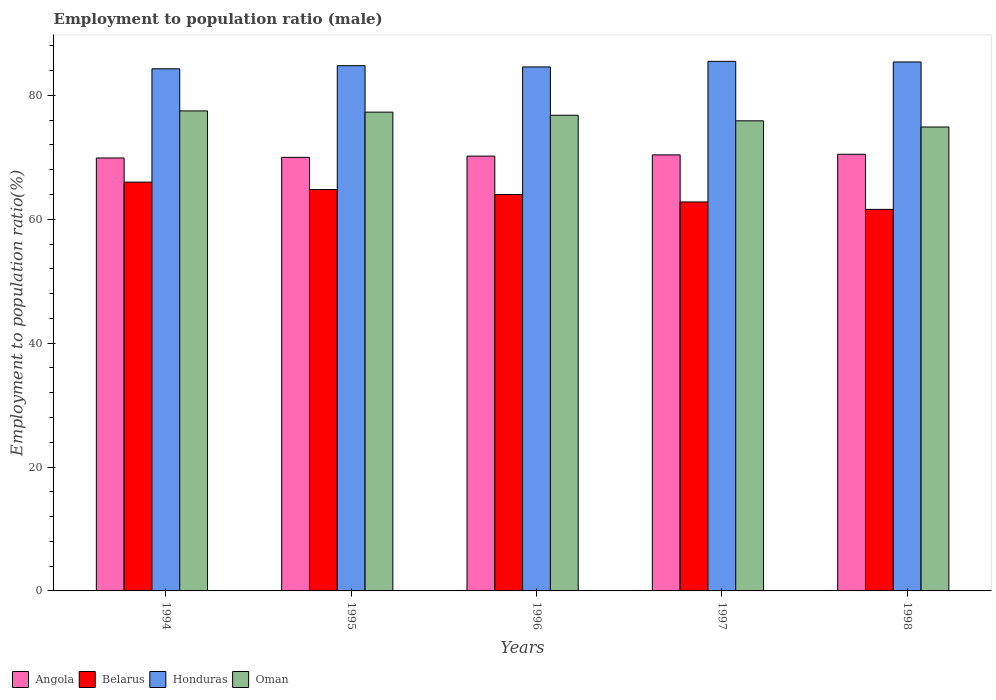Are the number of bars per tick equal to the number of legend labels?
Your response must be concise. Yes. How many bars are there on the 4th tick from the right?
Offer a very short reply. 4. What is the employment to population ratio in Honduras in 1994?
Your response must be concise. 84.3. Across all years, what is the maximum employment to population ratio in Oman?
Your response must be concise. 77.5. Across all years, what is the minimum employment to population ratio in Angola?
Your answer should be compact. 69.9. In which year was the employment to population ratio in Honduras maximum?
Provide a short and direct response. 1997. What is the total employment to population ratio in Honduras in the graph?
Give a very brief answer. 424.6. What is the difference between the employment to population ratio in Honduras in 1997 and that in 1998?
Offer a very short reply. 0.1. What is the difference between the employment to population ratio in Oman in 1998 and the employment to population ratio in Angola in 1995?
Provide a succinct answer. 4.9. What is the average employment to population ratio in Honduras per year?
Provide a succinct answer. 84.92. In the year 1995, what is the difference between the employment to population ratio in Belarus and employment to population ratio in Oman?
Your answer should be compact. -12.5. In how many years, is the employment to population ratio in Honduras greater than 20 %?
Give a very brief answer. 5. What is the ratio of the employment to population ratio in Oman in 1994 to that in 1997?
Offer a terse response. 1.02. Is the difference between the employment to population ratio in Belarus in 1994 and 1998 greater than the difference between the employment to population ratio in Oman in 1994 and 1998?
Make the answer very short. Yes. What is the difference between the highest and the second highest employment to population ratio in Oman?
Offer a very short reply. 0.2. What is the difference between the highest and the lowest employment to population ratio in Belarus?
Keep it short and to the point. 4.4. What does the 4th bar from the left in 1998 represents?
Your answer should be very brief. Oman. What does the 1st bar from the right in 1997 represents?
Your answer should be very brief. Oman. Is it the case that in every year, the sum of the employment to population ratio in Honduras and employment to population ratio in Belarus is greater than the employment to population ratio in Angola?
Your response must be concise. Yes. Are all the bars in the graph horizontal?
Offer a very short reply. No. Are the values on the major ticks of Y-axis written in scientific E-notation?
Offer a terse response. No. Where does the legend appear in the graph?
Make the answer very short. Bottom left. How many legend labels are there?
Keep it short and to the point. 4. What is the title of the graph?
Offer a terse response. Employment to population ratio (male). What is the label or title of the Y-axis?
Provide a succinct answer. Employment to population ratio(%). What is the Employment to population ratio(%) of Angola in 1994?
Give a very brief answer. 69.9. What is the Employment to population ratio(%) in Belarus in 1994?
Your answer should be very brief. 66. What is the Employment to population ratio(%) of Honduras in 1994?
Make the answer very short. 84.3. What is the Employment to population ratio(%) in Oman in 1994?
Your answer should be compact. 77.5. What is the Employment to population ratio(%) in Angola in 1995?
Your answer should be very brief. 70. What is the Employment to population ratio(%) of Belarus in 1995?
Offer a terse response. 64.8. What is the Employment to population ratio(%) in Honduras in 1995?
Offer a very short reply. 84.8. What is the Employment to population ratio(%) in Oman in 1995?
Provide a short and direct response. 77.3. What is the Employment to population ratio(%) in Angola in 1996?
Your answer should be compact. 70.2. What is the Employment to population ratio(%) in Belarus in 1996?
Make the answer very short. 64. What is the Employment to population ratio(%) of Honduras in 1996?
Your answer should be compact. 84.6. What is the Employment to population ratio(%) of Oman in 1996?
Give a very brief answer. 76.8. What is the Employment to population ratio(%) in Angola in 1997?
Your answer should be very brief. 70.4. What is the Employment to population ratio(%) of Belarus in 1997?
Keep it short and to the point. 62.8. What is the Employment to population ratio(%) in Honduras in 1997?
Your response must be concise. 85.5. What is the Employment to population ratio(%) of Oman in 1997?
Offer a very short reply. 75.9. What is the Employment to population ratio(%) of Angola in 1998?
Your answer should be very brief. 70.5. What is the Employment to population ratio(%) in Belarus in 1998?
Offer a very short reply. 61.6. What is the Employment to population ratio(%) in Honduras in 1998?
Offer a terse response. 85.4. What is the Employment to population ratio(%) of Oman in 1998?
Offer a terse response. 74.9. Across all years, what is the maximum Employment to population ratio(%) of Angola?
Offer a terse response. 70.5. Across all years, what is the maximum Employment to population ratio(%) of Honduras?
Provide a short and direct response. 85.5. Across all years, what is the maximum Employment to population ratio(%) in Oman?
Your response must be concise. 77.5. Across all years, what is the minimum Employment to population ratio(%) in Angola?
Keep it short and to the point. 69.9. Across all years, what is the minimum Employment to population ratio(%) of Belarus?
Give a very brief answer. 61.6. Across all years, what is the minimum Employment to population ratio(%) of Honduras?
Ensure brevity in your answer.  84.3. Across all years, what is the minimum Employment to population ratio(%) of Oman?
Your answer should be compact. 74.9. What is the total Employment to population ratio(%) in Angola in the graph?
Offer a terse response. 351. What is the total Employment to population ratio(%) in Belarus in the graph?
Give a very brief answer. 319.2. What is the total Employment to population ratio(%) of Honduras in the graph?
Provide a short and direct response. 424.6. What is the total Employment to population ratio(%) in Oman in the graph?
Give a very brief answer. 382.4. What is the difference between the Employment to population ratio(%) of Angola in 1994 and that in 1995?
Your answer should be very brief. -0.1. What is the difference between the Employment to population ratio(%) in Honduras in 1994 and that in 1995?
Give a very brief answer. -0.5. What is the difference between the Employment to population ratio(%) of Angola in 1994 and that in 1996?
Your answer should be compact. -0.3. What is the difference between the Employment to population ratio(%) in Belarus in 1994 and that in 1996?
Make the answer very short. 2. What is the difference between the Employment to population ratio(%) in Honduras in 1994 and that in 1996?
Offer a terse response. -0.3. What is the difference between the Employment to population ratio(%) of Oman in 1994 and that in 1996?
Provide a short and direct response. 0.7. What is the difference between the Employment to population ratio(%) in Angola in 1994 and that in 1997?
Give a very brief answer. -0.5. What is the difference between the Employment to population ratio(%) of Belarus in 1994 and that in 1997?
Keep it short and to the point. 3.2. What is the difference between the Employment to population ratio(%) of Angola in 1994 and that in 1998?
Make the answer very short. -0.6. What is the difference between the Employment to population ratio(%) of Belarus in 1994 and that in 1998?
Give a very brief answer. 4.4. What is the difference between the Employment to population ratio(%) in Honduras in 1994 and that in 1998?
Give a very brief answer. -1.1. What is the difference between the Employment to population ratio(%) of Belarus in 1995 and that in 1996?
Your response must be concise. 0.8. What is the difference between the Employment to population ratio(%) in Honduras in 1995 and that in 1996?
Make the answer very short. 0.2. What is the difference between the Employment to population ratio(%) of Angola in 1995 and that in 1998?
Your answer should be compact. -0.5. What is the difference between the Employment to population ratio(%) of Belarus in 1995 and that in 1998?
Your answer should be very brief. 3.2. What is the difference between the Employment to population ratio(%) of Oman in 1995 and that in 1998?
Your response must be concise. 2.4. What is the difference between the Employment to population ratio(%) of Belarus in 1996 and that in 1997?
Your answer should be compact. 1.2. What is the difference between the Employment to population ratio(%) of Honduras in 1996 and that in 1997?
Give a very brief answer. -0.9. What is the difference between the Employment to population ratio(%) in Oman in 1996 and that in 1997?
Make the answer very short. 0.9. What is the difference between the Employment to population ratio(%) of Honduras in 1996 and that in 1998?
Your answer should be compact. -0.8. What is the difference between the Employment to population ratio(%) of Angola in 1997 and that in 1998?
Your answer should be very brief. -0.1. What is the difference between the Employment to population ratio(%) of Belarus in 1997 and that in 1998?
Make the answer very short. 1.2. What is the difference between the Employment to population ratio(%) of Oman in 1997 and that in 1998?
Provide a short and direct response. 1. What is the difference between the Employment to population ratio(%) in Angola in 1994 and the Employment to population ratio(%) in Belarus in 1995?
Keep it short and to the point. 5.1. What is the difference between the Employment to population ratio(%) of Angola in 1994 and the Employment to population ratio(%) of Honduras in 1995?
Your answer should be very brief. -14.9. What is the difference between the Employment to population ratio(%) of Angola in 1994 and the Employment to population ratio(%) of Oman in 1995?
Provide a short and direct response. -7.4. What is the difference between the Employment to population ratio(%) in Belarus in 1994 and the Employment to population ratio(%) in Honduras in 1995?
Keep it short and to the point. -18.8. What is the difference between the Employment to population ratio(%) in Belarus in 1994 and the Employment to population ratio(%) in Oman in 1995?
Make the answer very short. -11.3. What is the difference between the Employment to population ratio(%) of Honduras in 1994 and the Employment to population ratio(%) of Oman in 1995?
Your answer should be very brief. 7. What is the difference between the Employment to population ratio(%) of Angola in 1994 and the Employment to population ratio(%) of Belarus in 1996?
Keep it short and to the point. 5.9. What is the difference between the Employment to population ratio(%) of Angola in 1994 and the Employment to population ratio(%) of Honduras in 1996?
Provide a short and direct response. -14.7. What is the difference between the Employment to population ratio(%) in Angola in 1994 and the Employment to population ratio(%) in Oman in 1996?
Ensure brevity in your answer.  -6.9. What is the difference between the Employment to population ratio(%) in Belarus in 1994 and the Employment to population ratio(%) in Honduras in 1996?
Offer a very short reply. -18.6. What is the difference between the Employment to population ratio(%) of Honduras in 1994 and the Employment to population ratio(%) of Oman in 1996?
Your answer should be very brief. 7.5. What is the difference between the Employment to population ratio(%) in Angola in 1994 and the Employment to population ratio(%) in Belarus in 1997?
Your answer should be compact. 7.1. What is the difference between the Employment to population ratio(%) of Angola in 1994 and the Employment to population ratio(%) of Honduras in 1997?
Your answer should be compact. -15.6. What is the difference between the Employment to population ratio(%) of Belarus in 1994 and the Employment to population ratio(%) of Honduras in 1997?
Offer a very short reply. -19.5. What is the difference between the Employment to population ratio(%) in Belarus in 1994 and the Employment to population ratio(%) in Oman in 1997?
Your answer should be compact. -9.9. What is the difference between the Employment to population ratio(%) in Angola in 1994 and the Employment to population ratio(%) in Honduras in 1998?
Provide a succinct answer. -15.5. What is the difference between the Employment to population ratio(%) of Belarus in 1994 and the Employment to population ratio(%) of Honduras in 1998?
Your answer should be compact. -19.4. What is the difference between the Employment to population ratio(%) of Belarus in 1994 and the Employment to population ratio(%) of Oman in 1998?
Ensure brevity in your answer.  -8.9. What is the difference between the Employment to population ratio(%) in Honduras in 1994 and the Employment to population ratio(%) in Oman in 1998?
Your answer should be very brief. 9.4. What is the difference between the Employment to population ratio(%) in Angola in 1995 and the Employment to population ratio(%) in Belarus in 1996?
Your answer should be very brief. 6. What is the difference between the Employment to population ratio(%) in Angola in 1995 and the Employment to population ratio(%) in Honduras in 1996?
Give a very brief answer. -14.6. What is the difference between the Employment to population ratio(%) of Angola in 1995 and the Employment to population ratio(%) of Oman in 1996?
Ensure brevity in your answer.  -6.8. What is the difference between the Employment to population ratio(%) of Belarus in 1995 and the Employment to population ratio(%) of Honduras in 1996?
Provide a succinct answer. -19.8. What is the difference between the Employment to population ratio(%) of Angola in 1995 and the Employment to population ratio(%) of Honduras in 1997?
Make the answer very short. -15.5. What is the difference between the Employment to population ratio(%) in Angola in 1995 and the Employment to population ratio(%) in Oman in 1997?
Offer a very short reply. -5.9. What is the difference between the Employment to population ratio(%) in Belarus in 1995 and the Employment to population ratio(%) in Honduras in 1997?
Keep it short and to the point. -20.7. What is the difference between the Employment to population ratio(%) of Angola in 1995 and the Employment to population ratio(%) of Belarus in 1998?
Keep it short and to the point. 8.4. What is the difference between the Employment to population ratio(%) in Angola in 1995 and the Employment to population ratio(%) in Honduras in 1998?
Offer a very short reply. -15.4. What is the difference between the Employment to population ratio(%) of Belarus in 1995 and the Employment to population ratio(%) of Honduras in 1998?
Provide a succinct answer. -20.6. What is the difference between the Employment to population ratio(%) of Angola in 1996 and the Employment to population ratio(%) of Honduras in 1997?
Offer a terse response. -15.3. What is the difference between the Employment to population ratio(%) of Angola in 1996 and the Employment to population ratio(%) of Oman in 1997?
Offer a terse response. -5.7. What is the difference between the Employment to population ratio(%) in Belarus in 1996 and the Employment to population ratio(%) in Honduras in 1997?
Give a very brief answer. -21.5. What is the difference between the Employment to population ratio(%) of Belarus in 1996 and the Employment to population ratio(%) of Oman in 1997?
Provide a succinct answer. -11.9. What is the difference between the Employment to population ratio(%) in Honduras in 1996 and the Employment to population ratio(%) in Oman in 1997?
Give a very brief answer. 8.7. What is the difference between the Employment to population ratio(%) in Angola in 1996 and the Employment to population ratio(%) in Honduras in 1998?
Offer a terse response. -15.2. What is the difference between the Employment to population ratio(%) in Belarus in 1996 and the Employment to population ratio(%) in Honduras in 1998?
Your response must be concise. -21.4. What is the difference between the Employment to population ratio(%) of Belarus in 1996 and the Employment to population ratio(%) of Oman in 1998?
Offer a terse response. -10.9. What is the difference between the Employment to population ratio(%) of Belarus in 1997 and the Employment to population ratio(%) of Honduras in 1998?
Your answer should be very brief. -22.6. What is the average Employment to population ratio(%) of Angola per year?
Your answer should be very brief. 70.2. What is the average Employment to population ratio(%) in Belarus per year?
Keep it short and to the point. 63.84. What is the average Employment to population ratio(%) in Honduras per year?
Your response must be concise. 84.92. What is the average Employment to population ratio(%) of Oman per year?
Your answer should be compact. 76.48. In the year 1994, what is the difference between the Employment to population ratio(%) in Angola and Employment to population ratio(%) in Honduras?
Provide a succinct answer. -14.4. In the year 1994, what is the difference between the Employment to population ratio(%) of Angola and Employment to population ratio(%) of Oman?
Offer a terse response. -7.6. In the year 1994, what is the difference between the Employment to population ratio(%) of Belarus and Employment to population ratio(%) of Honduras?
Ensure brevity in your answer.  -18.3. In the year 1994, what is the difference between the Employment to population ratio(%) in Belarus and Employment to population ratio(%) in Oman?
Your answer should be very brief. -11.5. In the year 1994, what is the difference between the Employment to population ratio(%) of Honduras and Employment to population ratio(%) of Oman?
Ensure brevity in your answer.  6.8. In the year 1995, what is the difference between the Employment to population ratio(%) of Angola and Employment to population ratio(%) of Belarus?
Ensure brevity in your answer.  5.2. In the year 1995, what is the difference between the Employment to population ratio(%) of Angola and Employment to population ratio(%) of Honduras?
Your answer should be very brief. -14.8. In the year 1995, what is the difference between the Employment to population ratio(%) in Belarus and Employment to population ratio(%) in Honduras?
Your response must be concise. -20. In the year 1995, what is the difference between the Employment to population ratio(%) in Belarus and Employment to population ratio(%) in Oman?
Provide a short and direct response. -12.5. In the year 1996, what is the difference between the Employment to population ratio(%) in Angola and Employment to population ratio(%) in Belarus?
Make the answer very short. 6.2. In the year 1996, what is the difference between the Employment to population ratio(%) of Angola and Employment to population ratio(%) of Honduras?
Your answer should be very brief. -14.4. In the year 1996, what is the difference between the Employment to population ratio(%) of Belarus and Employment to population ratio(%) of Honduras?
Ensure brevity in your answer.  -20.6. In the year 1996, what is the difference between the Employment to population ratio(%) of Belarus and Employment to population ratio(%) of Oman?
Make the answer very short. -12.8. In the year 1997, what is the difference between the Employment to population ratio(%) in Angola and Employment to population ratio(%) in Honduras?
Provide a succinct answer. -15.1. In the year 1997, what is the difference between the Employment to population ratio(%) of Angola and Employment to population ratio(%) of Oman?
Your answer should be compact. -5.5. In the year 1997, what is the difference between the Employment to population ratio(%) in Belarus and Employment to population ratio(%) in Honduras?
Provide a succinct answer. -22.7. In the year 1997, what is the difference between the Employment to population ratio(%) in Belarus and Employment to population ratio(%) in Oman?
Your response must be concise. -13.1. In the year 1998, what is the difference between the Employment to population ratio(%) in Angola and Employment to population ratio(%) in Honduras?
Make the answer very short. -14.9. In the year 1998, what is the difference between the Employment to population ratio(%) in Belarus and Employment to population ratio(%) in Honduras?
Give a very brief answer. -23.8. What is the ratio of the Employment to population ratio(%) of Angola in 1994 to that in 1995?
Your response must be concise. 1. What is the ratio of the Employment to population ratio(%) of Belarus in 1994 to that in 1995?
Give a very brief answer. 1.02. What is the ratio of the Employment to population ratio(%) in Honduras in 1994 to that in 1995?
Give a very brief answer. 0.99. What is the ratio of the Employment to population ratio(%) in Oman in 1994 to that in 1995?
Provide a succinct answer. 1. What is the ratio of the Employment to population ratio(%) in Belarus in 1994 to that in 1996?
Provide a succinct answer. 1.03. What is the ratio of the Employment to population ratio(%) of Oman in 1994 to that in 1996?
Provide a short and direct response. 1.01. What is the ratio of the Employment to population ratio(%) in Angola in 1994 to that in 1997?
Your answer should be compact. 0.99. What is the ratio of the Employment to population ratio(%) of Belarus in 1994 to that in 1997?
Offer a terse response. 1.05. What is the ratio of the Employment to population ratio(%) in Oman in 1994 to that in 1997?
Ensure brevity in your answer.  1.02. What is the ratio of the Employment to population ratio(%) of Belarus in 1994 to that in 1998?
Keep it short and to the point. 1.07. What is the ratio of the Employment to population ratio(%) in Honduras in 1994 to that in 1998?
Provide a short and direct response. 0.99. What is the ratio of the Employment to population ratio(%) in Oman in 1994 to that in 1998?
Ensure brevity in your answer.  1.03. What is the ratio of the Employment to population ratio(%) in Angola in 1995 to that in 1996?
Ensure brevity in your answer.  1. What is the ratio of the Employment to population ratio(%) of Belarus in 1995 to that in 1996?
Ensure brevity in your answer.  1.01. What is the ratio of the Employment to population ratio(%) in Oman in 1995 to that in 1996?
Your answer should be compact. 1.01. What is the ratio of the Employment to population ratio(%) of Angola in 1995 to that in 1997?
Provide a short and direct response. 0.99. What is the ratio of the Employment to population ratio(%) in Belarus in 1995 to that in 1997?
Keep it short and to the point. 1.03. What is the ratio of the Employment to population ratio(%) in Oman in 1995 to that in 1997?
Ensure brevity in your answer.  1.02. What is the ratio of the Employment to population ratio(%) of Angola in 1995 to that in 1998?
Ensure brevity in your answer.  0.99. What is the ratio of the Employment to population ratio(%) of Belarus in 1995 to that in 1998?
Make the answer very short. 1.05. What is the ratio of the Employment to population ratio(%) in Oman in 1995 to that in 1998?
Your response must be concise. 1.03. What is the ratio of the Employment to population ratio(%) in Belarus in 1996 to that in 1997?
Keep it short and to the point. 1.02. What is the ratio of the Employment to population ratio(%) of Honduras in 1996 to that in 1997?
Offer a terse response. 0.99. What is the ratio of the Employment to population ratio(%) in Oman in 1996 to that in 1997?
Give a very brief answer. 1.01. What is the ratio of the Employment to population ratio(%) of Angola in 1996 to that in 1998?
Provide a short and direct response. 1. What is the ratio of the Employment to population ratio(%) of Belarus in 1996 to that in 1998?
Ensure brevity in your answer.  1.04. What is the ratio of the Employment to population ratio(%) in Honduras in 1996 to that in 1998?
Make the answer very short. 0.99. What is the ratio of the Employment to population ratio(%) in Oman in 1996 to that in 1998?
Offer a very short reply. 1.03. What is the ratio of the Employment to population ratio(%) of Belarus in 1997 to that in 1998?
Your answer should be compact. 1.02. What is the ratio of the Employment to population ratio(%) of Honduras in 1997 to that in 1998?
Offer a very short reply. 1. What is the ratio of the Employment to population ratio(%) of Oman in 1997 to that in 1998?
Keep it short and to the point. 1.01. What is the difference between the highest and the second highest Employment to population ratio(%) of Belarus?
Give a very brief answer. 1.2. What is the difference between the highest and the second highest Employment to population ratio(%) in Oman?
Ensure brevity in your answer.  0.2. What is the difference between the highest and the lowest Employment to population ratio(%) in Angola?
Ensure brevity in your answer.  0.6. What is the difference between the highest and the lowest Employment to population ratio(%) in Belarus?
Keep it short and to the point. 4.4. What is the difference between the highest and the lowest Employment to population ratio(%) in Honduras?
Offer a very short reply. 1.2. What is the difference between the highest and the lowest Employment to population ratio(%) in Oman?
Your response must be concise. 2.6. 